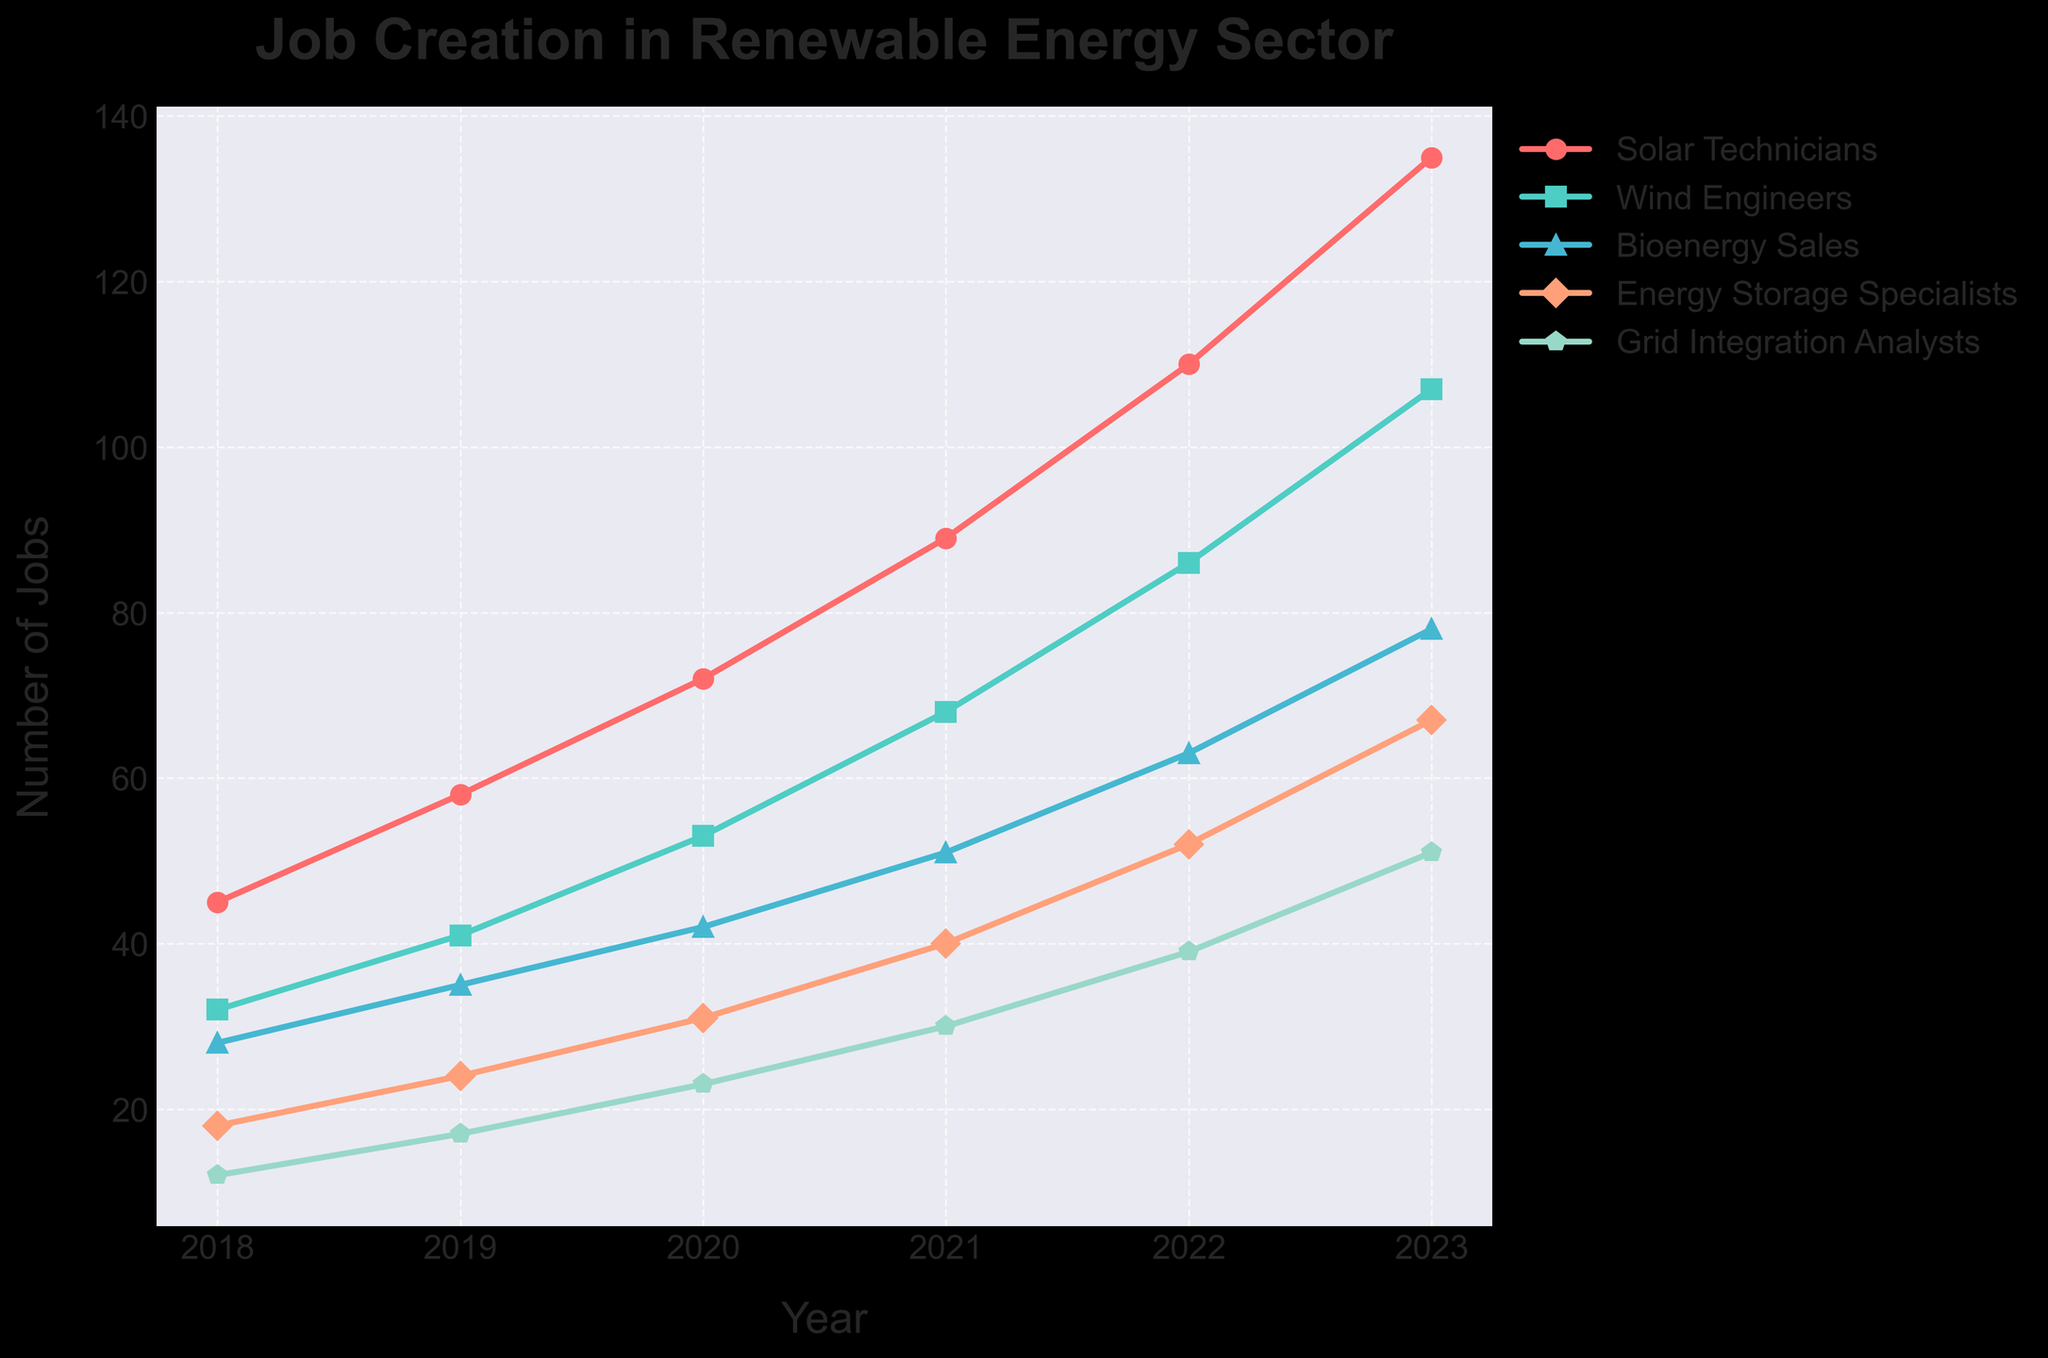Which job role had the highest number of jobs created in 2023? The plot shows five different job roles. Comparing their values for the year 2023, Solar Technicians had the highest value at 135.
Answer: Solar Technicians What was the total number of jobs created in 2020? Summing the number of jobs for each role in 2020 gives 72 + 53 + 42 + 31 + 23. This results in 221.
Answer: 221 Which role saw the greatest increase in jobs from 2018 to 2023? Calculating the difference in jobs from 2018 to 2023 for each role:
- Solar Technicians: 135 - 45 = 90
- Wind Engineers: 107 - 32 = 75
- Bioenergy Sales: 78 - 28 = 50
- Energy Storage Specialists: 67 - 18 = 49
- Grid Integration Analysts: 51 - 12 = 39
Solar Technicians saw the greatest increase of 90 jobs.
Answer: Solar Technicians How many more jobs did Wind Engineers have compared to Grid Integration Analysts in 2022? The number of jobs in 2022 for Wind Engineers is 86, and for Grid Integration Analysts is 39. The difference is 86 - 39.
Answer: 47 Which job roles had the same trends in job growth from 2019 to 2020? Examining the slope of the lines from 2019 to 2020, both Solar Technicians and Wind Engineers show similar steepness in growth while the others have varied trends.
Answer: Solar Technicians and Wind Engineers What's the average annual increase of jobs for Bioenergy Sales between 2018 and 2023? Calculating the annual increase:
2018 to 2019: 35 - 28 = 7
2019 to 2020: 42 - 35 = 7
2020 to 2021: 51 - 42 = 9
2021 to 2022: 63 - 52 = 11
2022 to 2023: 78 - 63 = 15
Average increase = (7 + 7 + 9 + 11 + 15) / 5 = 49 / 5 = 9.8
Answer: 9.8 By what percentage did Energy Storage Specialists' jobs increase from 2021 to 2023? Calculating the percentage increase:
2021 to 2023: 67 - 40 = 27
Percentage increase = (27 / 40) * 100 = 67.5%
Answer: 67.5% Which job role had the lowest number of jobs created in 2021 and how many were there? Referring to the values in 2021, Grid Integration Analysts had the lowest number of jobs at 30.
Answer: Grid Integration Analysts (30) 